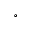Convert formula to latex. <formula><loc_0><loc_0><loc_500><loc_500>^ { \circ }</formula> 